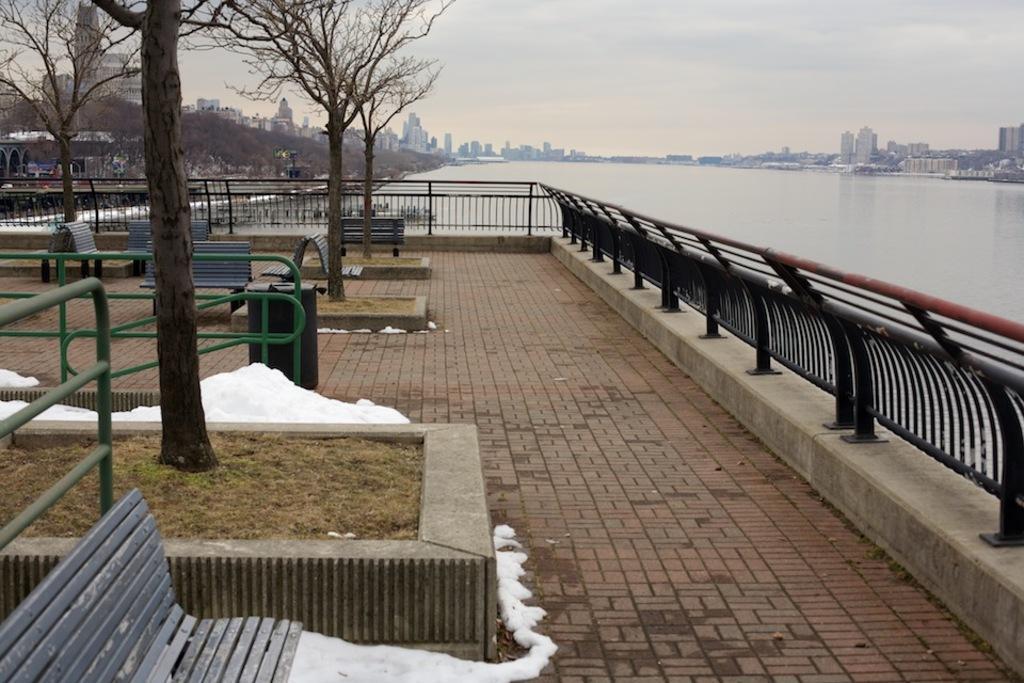Describe this image in one or two sentences. In this image we can see trees, benches, iron railing, water and in the background there are buildings and sky. 